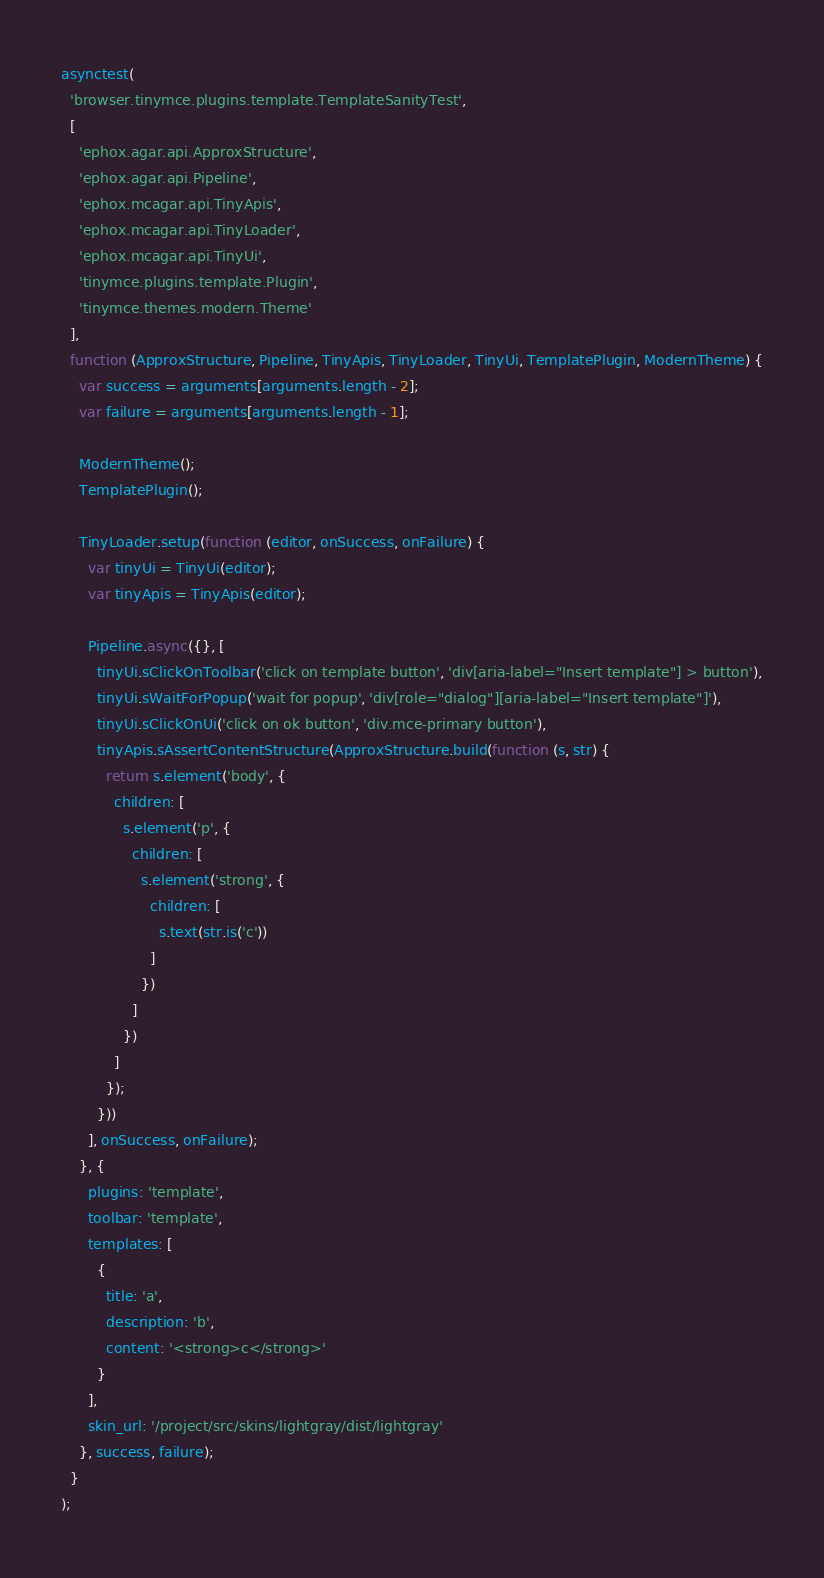<code> <loc_0><loc_0><loc_500><loc_500><_JavaScript_>asynctest(
  'browser.tinymce.plugins.template.TemplateSanityTest',
  [
    'ephox.agar.api.ApproxStructure',
    'ephox.agar.api.Pipeline',
    'ephox.mcagar.api.TinyApis',
    'ephox.mcagar.api.TinyLoader',
    'ephox.mcagar.api.TinyUi',
    'tinymce.plugins.template.Plugin',
    'tinymce.themes.modern.Theme'
  ],
  function (ApproxStructure, Pipeline, TinyApis, TinyLoader, TinyUi, TemplatePlugin, ModernTheme) {
    var success = arguments[arguments.length - 2];
    var failure = arguments[arguments.length - 1];

    ModernTheme();
    TemplatePlugin();

    TinyLoader.setup(function (editor, onSuccess, onFailure) {
      var tinyUi = TinyUi(editor);
      var tinyApis = TinyApis(editor);

      Pipeline.async({}, [
        tinyUi.sClickOnToolbar('click on template button', 'div[aria-label="Insert template"] > button'),
        tinyUi.sWaitForPopup('wait for popup', 'div[role="dialog"][aria-label="Insert template"]'),
        tinyUi.sClickOnUi('click on ok button', 'div.mce-primary button'),
        tinyApis.sAssertContentStructure(ApproxStructure.build(function (s, str) {
          return s.element('body', {
            children: [
              s.element('p', {
                children: [
                  s.element('strong', {
                    children: [
                      s.text(str.is('c'))
                    ]
                  })
                ]
              })
            ]
          });
        }))
      ], onSuccess, onFailure);
    }, {
      plugins: 'template',
      toolbar: 'template',
      templates: [
        {
          title: 'a',
          description: 'b',
          content: '<strong>c</strong>'
        }
      ],
      skin_url: '/project/src/skins/lightgray/dist/lightgray'
    }, success, failure);
  }
);</code> 